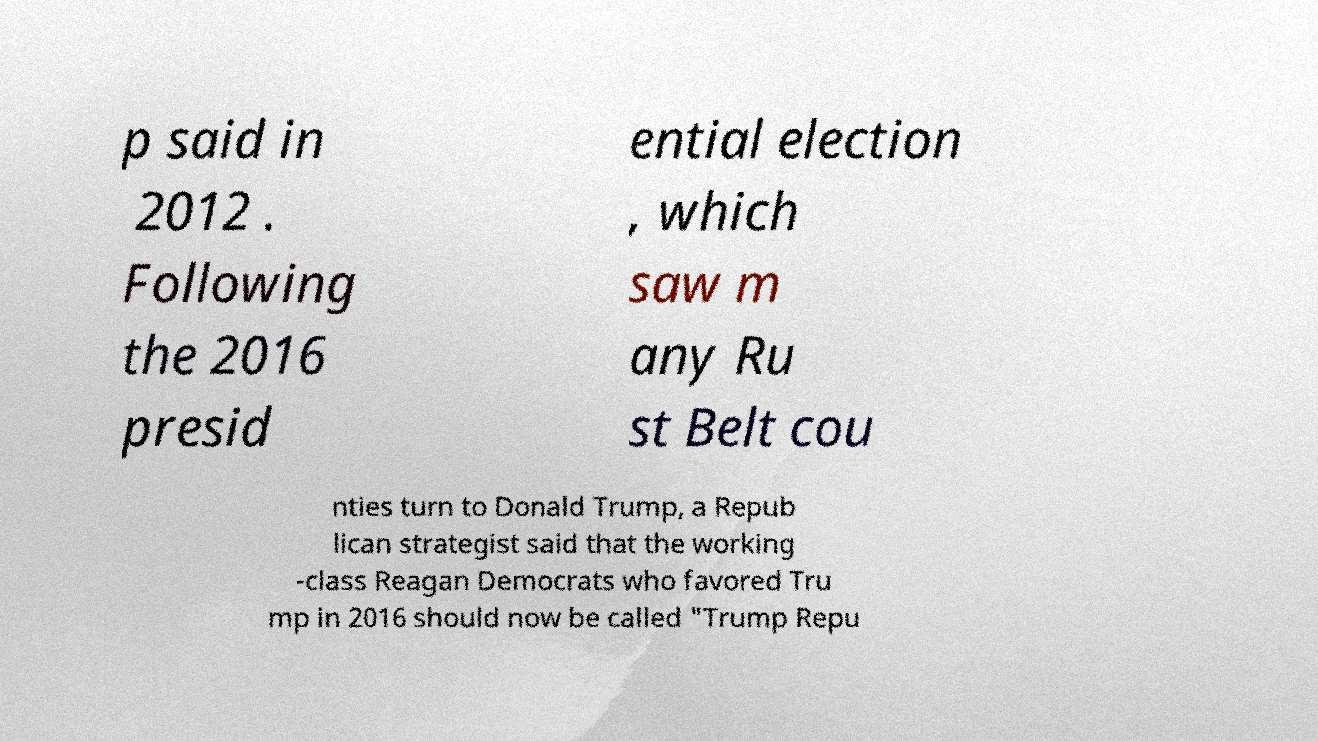Could you extract and type out the text from this image? p said in 2012 . Following the 2016 presid ential election , which saw m any Ru st Belt cou nties turn to Donald Trump, a Repub lican strategist said that the working -class Reagan Democrats who favored Tru mp in 2016 should now be called "Trump Repu 